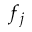Convert formula to latex. <formula><loc_0><loc_0><loc_500><loc_500>f _ { j }</formula> 